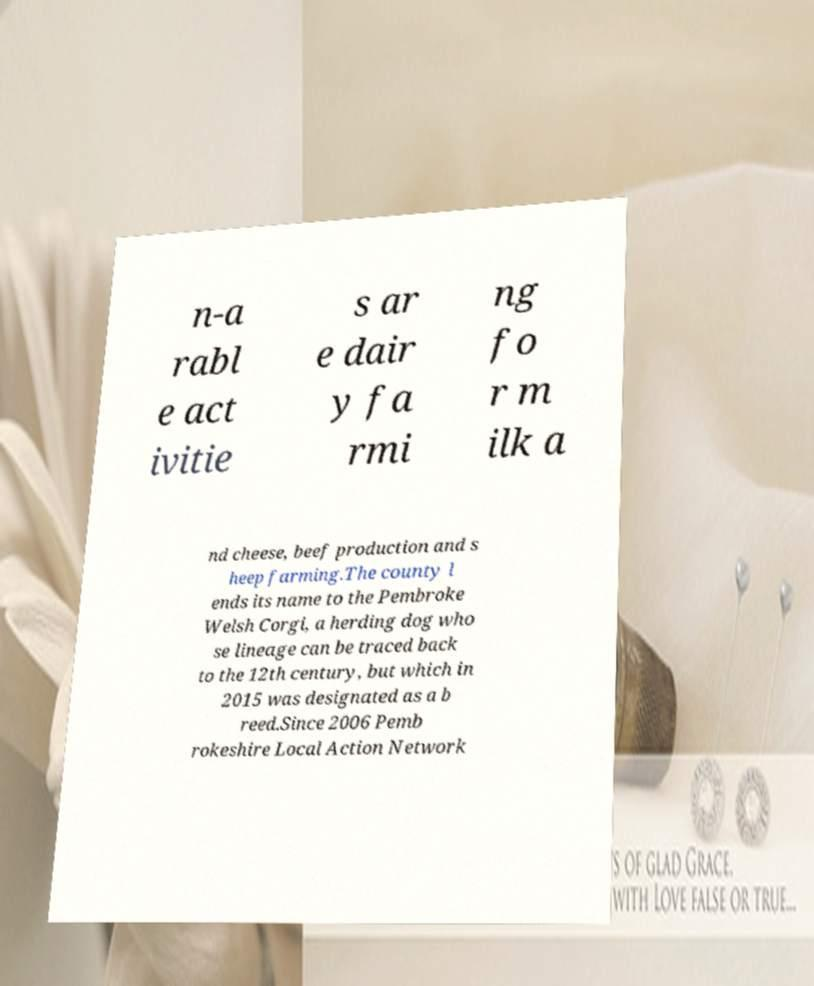There's text embedded in this image that I need extracted. Can you transcribe it verbatim? n-a rabl e act ivitie s ar e dair y fa rmi ng fo r m ilk a nd cheese, beef production and s heep farming.The county l ends its name to the Pembroke Welsh Corgi, a herding dog who se lineage can be traced back to the 12th century, but which in 2015 was designated as a b reed.Since 2006 Pemb rokeshire Local Action Network 